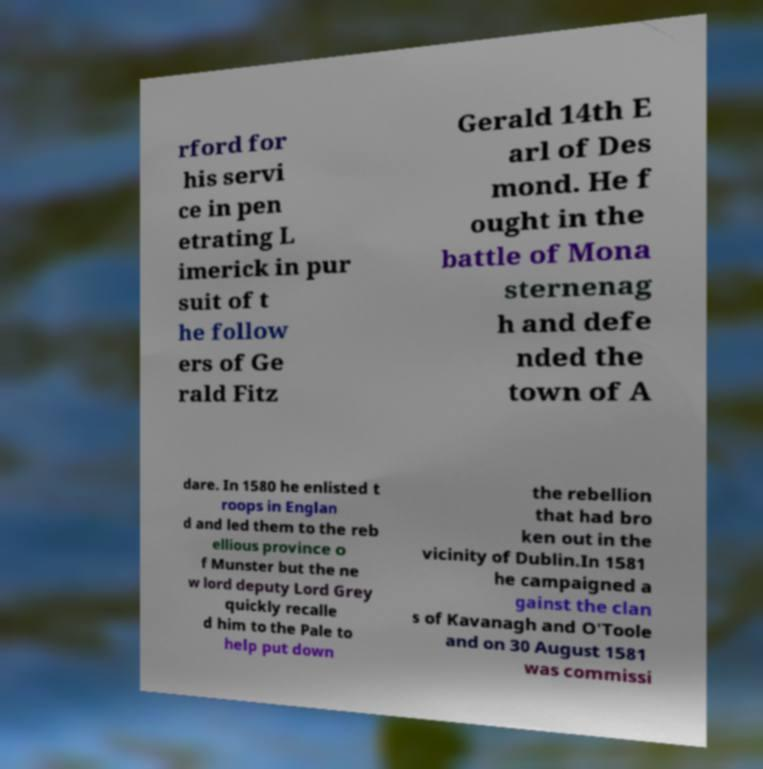Please read and relay the text visible in this image. What does it say? rford for his servi ce in pen etrating L imerick in pur suit of t he follow ers of Ge rald Fitz Gerald 14th E arl of Des mond. He f ought in the battle of Mona sternenag h and defe nded the town of A dare. In 1580 he enlisted t roops in Englan d and led them to the reb ellious province o f Munster but the ne w lord deputy Lord Grey quickly recalle d him to the Pale to help put down the rebellion that had bro ken out in the vicinity of Dublin.In 1581 he campaigned a gainst the clan s of Kavanagh and O'Toole and on 30 August 1581 was commissi 